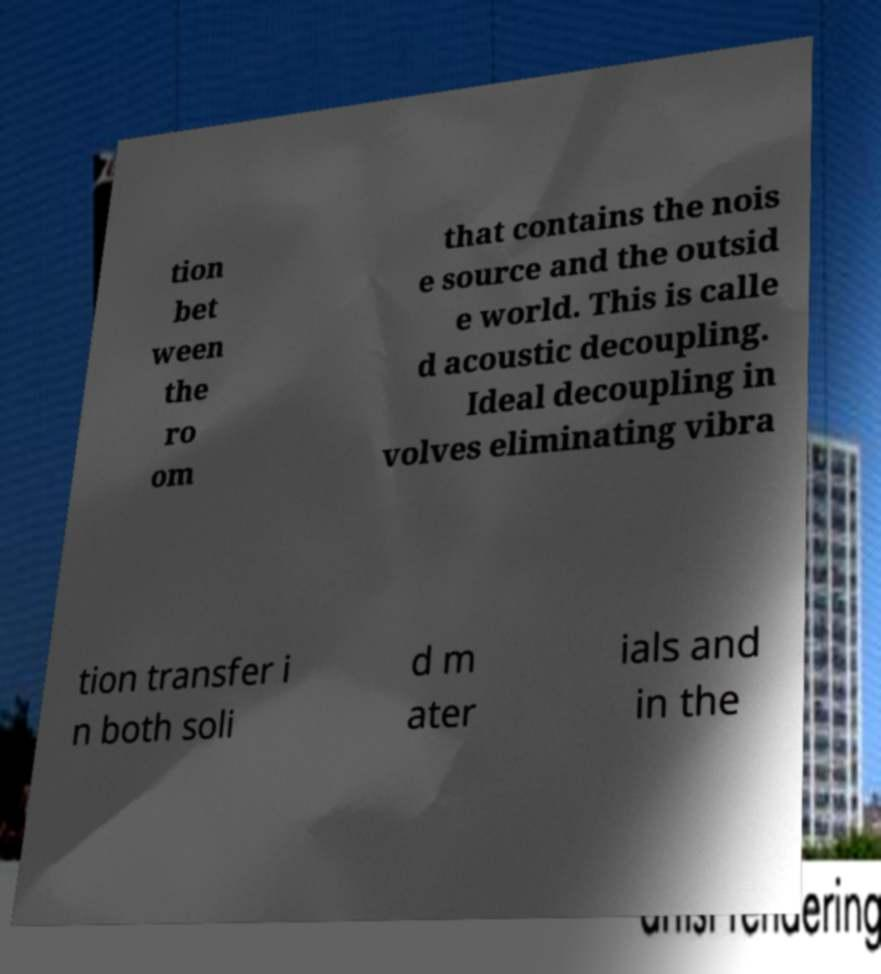Can you read and provide the text displayed in the image?This photo seems to have some interesting text. Can you extract and type it out for me? tion bet ween the ro om that contains the nois e source and the outsid e world. This is calle d acoustic decoupling. Ideal decoupling in volves eliminating vibra tion transfer i n both soli d m ater ials and in the 